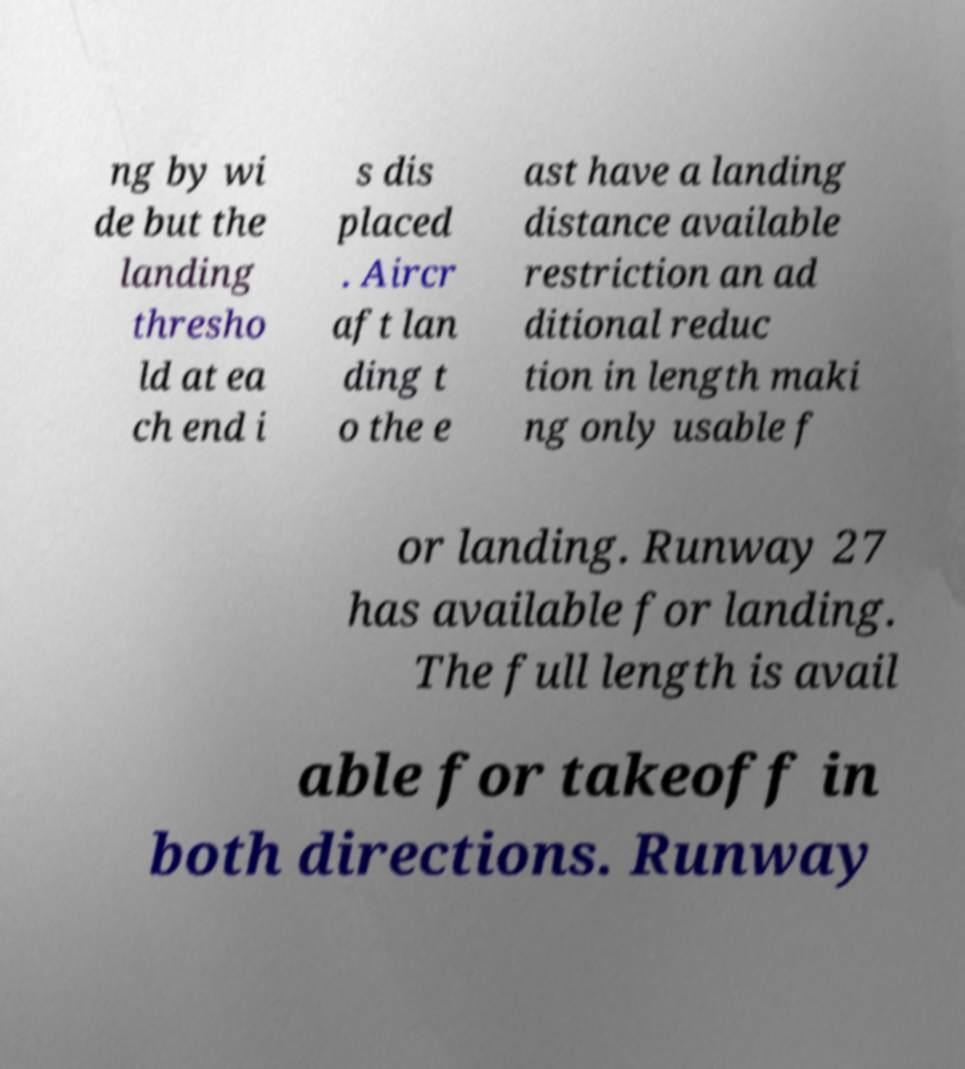For documentation purposes, I need the text within this image transcribed. Could you provide that? ng by wi de but the landing thresho ld at ea ch end i s dis placed . Aircr aft lan ding t o the e ast have a landing distance available restriction an ad ditional reduc tion in length maki ng only usable f or landing. Runway 27 has available for landing. The full length is avail able for takeoff in both directions. Runway 